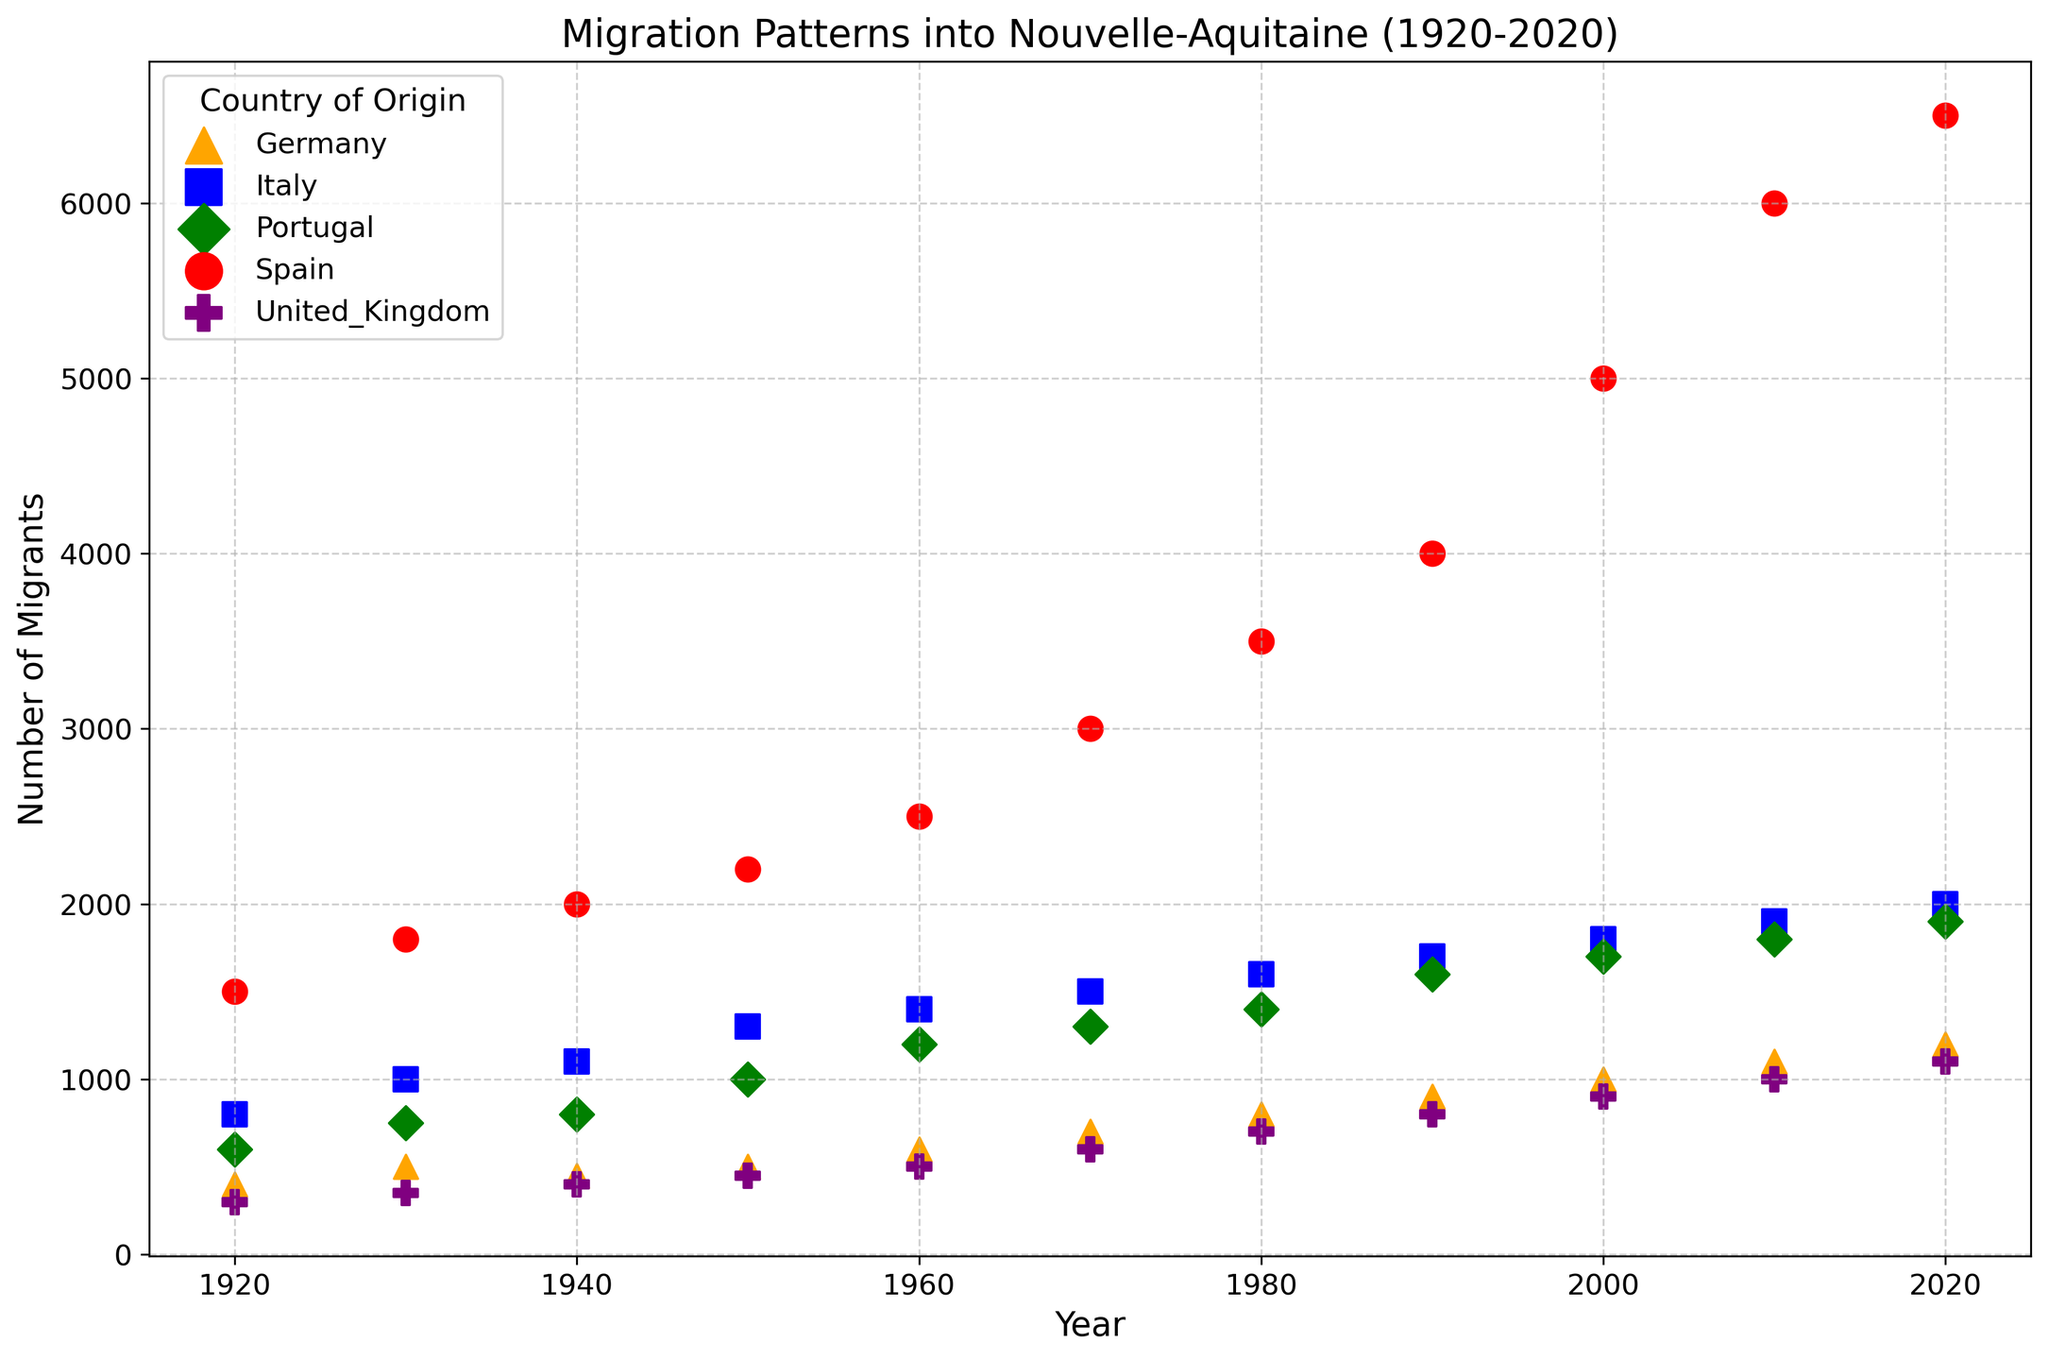What country had the most migrants to Nouvelle-Aquitaine in 2020? First, note the colors and markers for each country. Check the data points for 2020, identify the highest point on the scatter plot. The largest number of migrants is indicated by the highest scatter point, which corresponds to Spain.
Answer: Spain For which decade did migration from Portugal first exceed 1000 migrants? Identify the scatter points for Portugal (green diamonds) across all decades. The decade where Portugal has more than 1000 migrants is the 1950s.
Answer: 1950s How many more migrants were there from Spain than from Italy in 2010? Find the 2010 data points for Spain (red circles) and Italy (blue squares). Spain had 6000 migrants, and Italy had 1900 migrants. Subtract Italy's migrants from Spain's: 6000 - 1900 = 4100.
Answer: 4100 Which two countries had the same number of migrants in the 1940s? Locate the 1940 data points. Spain, Italy, and Portugal show different numbers. Germany and the United Kingdom each have 450 migrants. Hence, Germany and the United Kingdom had the same number of migrants in the 1940s.
Answer: Germany and United Kingdom Did the number of migrants from Germany ever surpass 1000? Track the scatter points for Germany (orange triangles) over the years. The highest number of German migrants is in 2020, which is 1200. Therefore, the number of German migrants surpasses 1000 in 2020.
Answer: Yes Which decade saw the greatest increase in migrants from Spain? Examine the red circles for Spain across the decades. Calculate the increase between each decade: 
1930-1920: 1800-1500=300 
1940-1930: 2000-1800=200 
1950-1940: 2200-2000=200
1960-1950: 2500-2200=300 
1970-1960: 3000-2500=500 
1980-1970: 3500-3000=500 
1990-1980: 4000-3500=500 
2000-1990: 5000-4000=1000 
2010-2000: 6000-5000=1000
2020-2010: 6500-6000=500. 
The greatest increase was between 1990-2000 and 2000-2010, each rising by 1000.
Answer: 2000s From which country did the number of migrants increase the least between 1920 and 2020? Evaluate the difference in migration from each country over this period: 
Spain: 6500-1500=5000 
Italy: 2000-800=1200 
Portugal: 1900-600=1300 
Germany: 1200-400=800 
United Kingdom: 1100-300=800. 
Germany and United Kingdom had the smallest increases of 800 each.
Answer: Germany and United Kingdom What country had a consistent increase in migrant numbers every decade? Observe each country's scatter points from 1920 to 2020. Spain, Portugal, and United Kingdom show steady increases each decade without any decrease. Spain, however, had the most consistent incremental increase.
Answer: Spain 